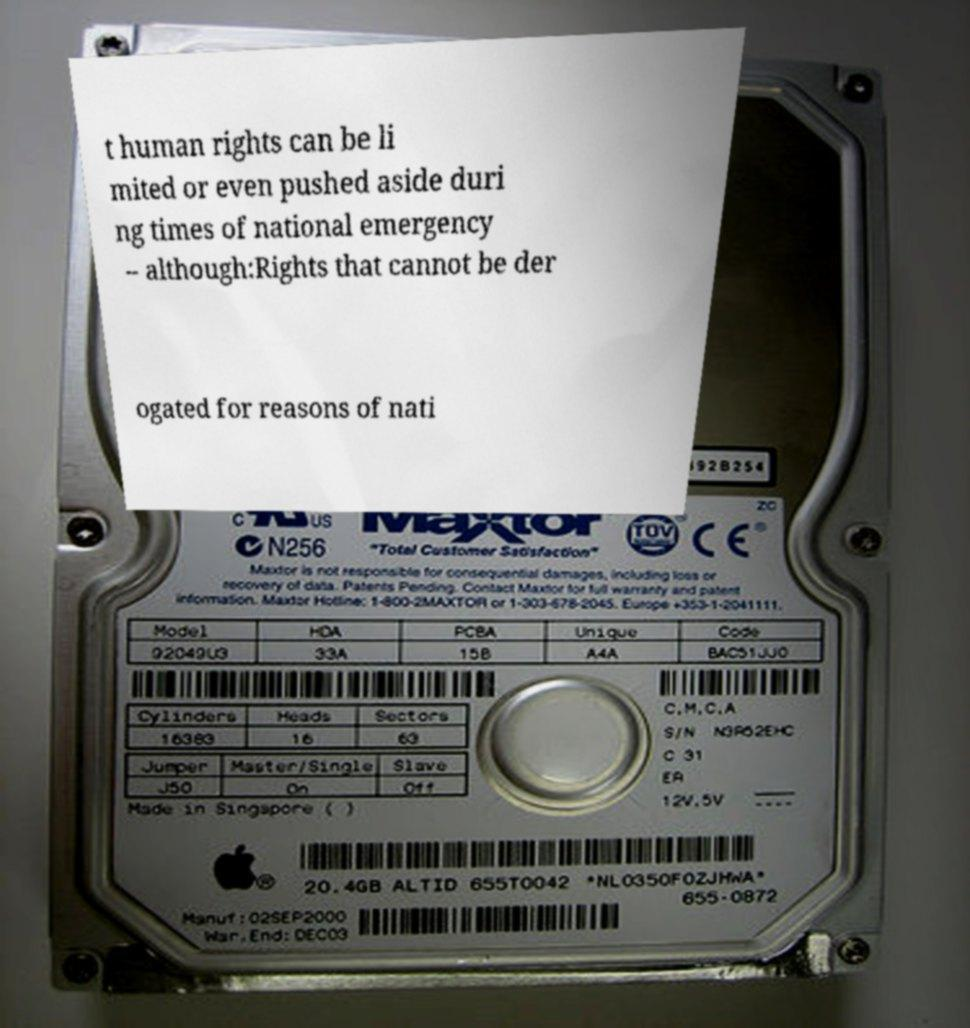What messages or text are displayed in this image? I need them in a readable, typed format. t human rights can be li mited or even pushed aside duri ng times of national emergency – although:Rights that cannot be der ogated for reasons of nati 